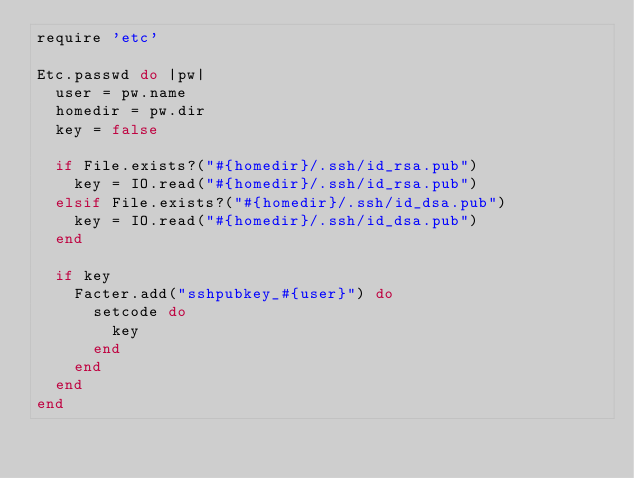Convert code to text. <code><loc_0><loc_0><loc_500><loc_500><_Ruby_>require 'etc'

Etc.passwd do |pw|
  user = pw.name
  homedir = pw.dir
  key = false

  if File.exists?("#{homedir}/.ssh/id_rsa.pub")
    key = IO.read("#{homedir}/.ssh/id_rsa.pub")
  elsif File.exists?("#{homedir}/.ssh/id_dsa.pub")
    key = IO.read("#{homedir}/.ssh/id_dsa.pub")
  end

  if key
    Facter.add("sshpubkey_#{user}") do
      setcode do
        key
      end
    end
  end
end
</code> 